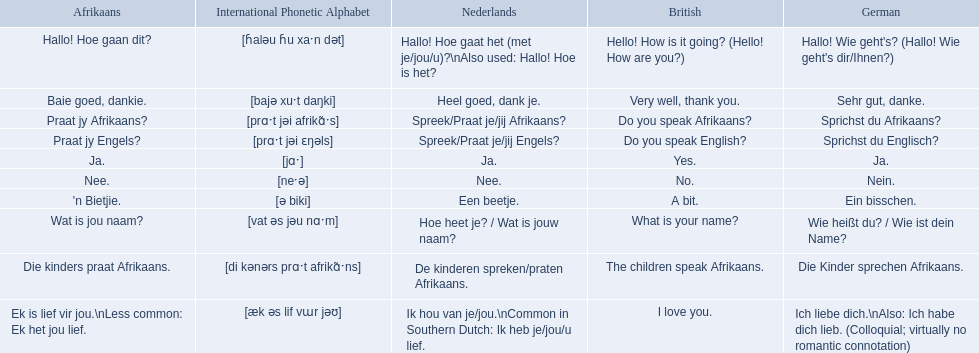What are all of the afrikaans phrases shown in the table? Hallo! Hoe gaan dit?, Baie goed, dankie., Praat jy Afrikaans?, Praat jy Engels?, Ja., Nee., 'n Bietjie., Wat is jou naam?, Die kinders praat Afrikaans., Ek is lief vir jou.\nLess common: Ek het jou lief. Of those, which translates into english as do you speak afrikaans?? Praat jy Afrikaans?. 